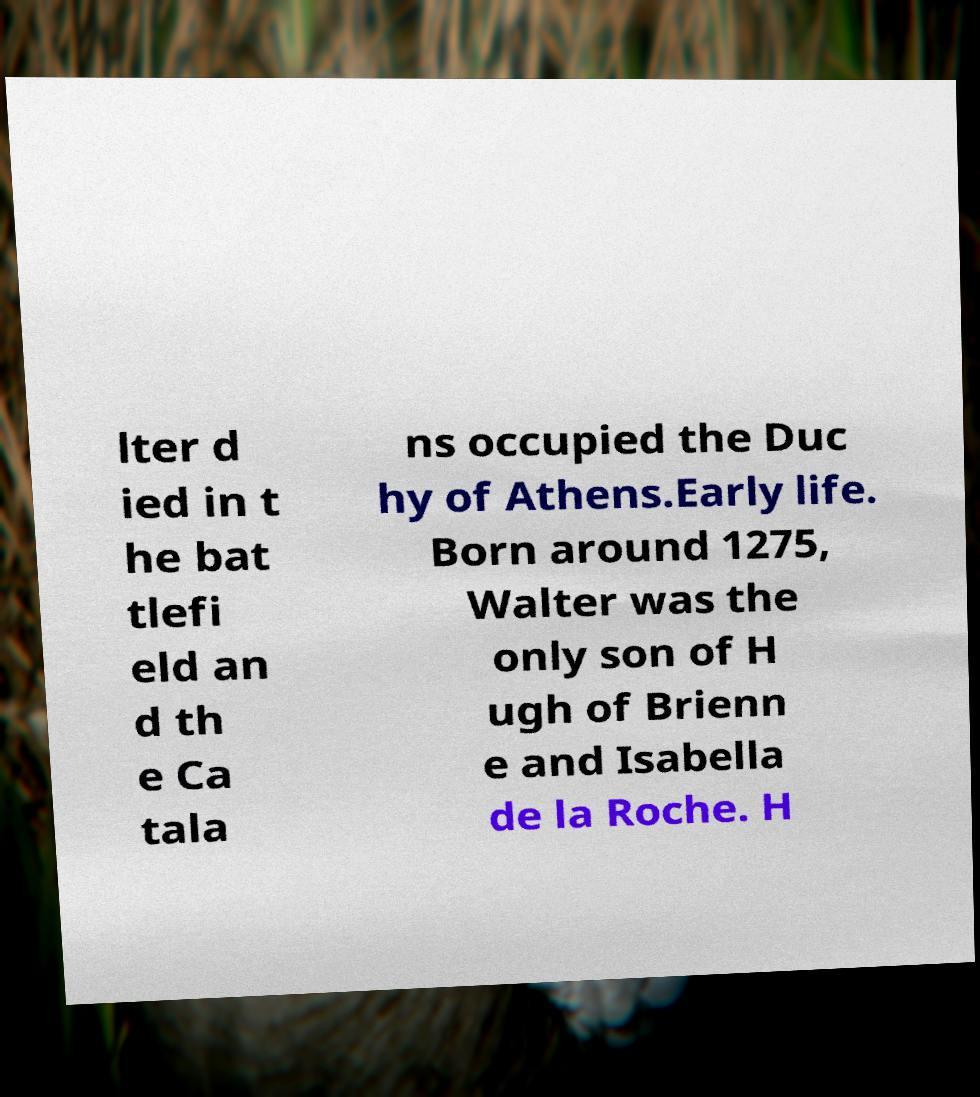What messages or text are displayed in this image? I need them in a readable, typed format. lter d ied in t he bat tlefi eld an d th e Ca tala ns occupied the Duc hy of Athens.Early life. Born around 1275, Walter was the only son of H ugh of Brienn e and Isabella de la Roche. H 